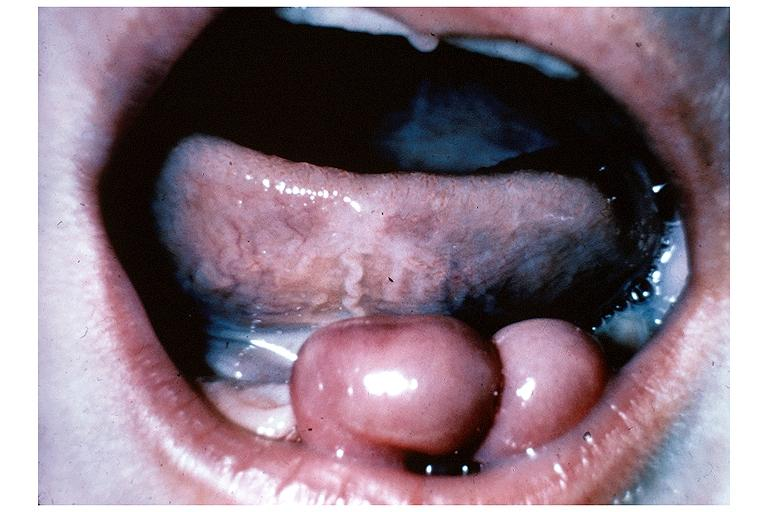s amyloid angiopathy r. endocrine present?
Answer the question using a single word or phrase. No 